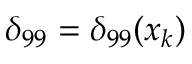<formula> <loc_0><loc_0><loc_500><loc_500>\delta _ { 9 9 } = \delta _ { 9 9 } ( x _ { k } )</formula> 